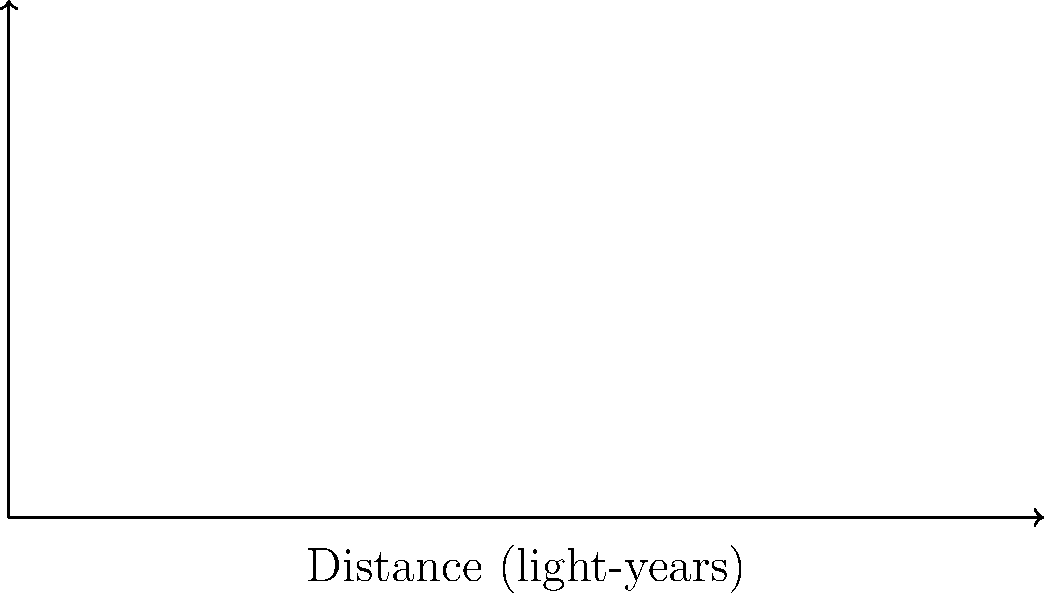As the head of an organization leveraging AI to tackle homelessness and poverty, you're explaining the vastness of space to potential donors. Using the concept of light-years, how would you describe the distance to Betelgeuse in a way that emphasizes the scale of the universe and the importance of thinking big when addressing global issues? To answer this question, let's break down the concept of light-years and relate it to the distance of Betelgeuse:

1. Definition of a light-year: The distance light travels in one year, approximately $9.46 \times 10^{12}$ km or $5.88 \times 10^{12}$ miles.

2. Betelgeuse's distance: From the diagram, we can see that Betelgeuse is about 642.5 light-years away.

3. Putting it into perspective:
   a) If we could travel at the speed of light, it would take 642.5 years to reach Betelgeuse.
   b) For comparison, Proxima Centauri (our nearest star) is only 4.2 light-years away.
   c) The distance to Betelgeuse is about 153 times farther than Proxima Centauri.

4. Relating to global issues:
   a) Just as the distance to Betelgeuse seems insurmountable, global issues like homelessness and poverty can seem overwhelming.
   b) However, just as we've developed tools to measure and understand vast cosmic distances, we can use AI and other technologies to tackle these complex social issues.
   c) The scale of the universe reminds us that no problem is too big if we approach it with the right tools and perspective.

5. Emphasis on thinking big:
   a) If we can contemplate and study objects as far as Betelgeuse, we can certainly think on a global scale for solving earthly problems.
   b) The vastness of space encourages us to expand our horizons and think beyond immediate, local solutions to develop comprehensive, far-reaching strategies.
Answer: Betelgeuse is 642.5 light-years away, emphasizing the vast scale of the universe and inspiring us to think big and use innovative tools like AI when addressing global issues such as homelessness and poverty. 